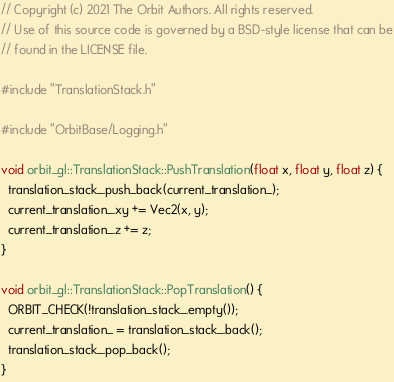<code> <loc_0><loc_0><loc_500><loc_500><_C++_>// Copyright (c) 2021 The Orbit Authors. All rights reserved.
// Use of this source code is governed by a BSD-style license that can be
// found in the LICENSE file.

#include "TranslationStack.h"

#include "OrbitBase/Logging.h"

void orbit_gl::TranslationStack::PushTranslation(float x, float y, float z) {
  translation_stack_.push_back(current_translation_);
  current_translation_.xy += Vec2(x, y);
  current_translation_.z += z;
}

void orbit_gl::TranslationStack::PopTranslation() {
  ORBIT_CHECK(!translation_stack_.empty());
  current_translation_ = translation_stack_.back();
  translation_stack_.pop_back();
}
</code> 